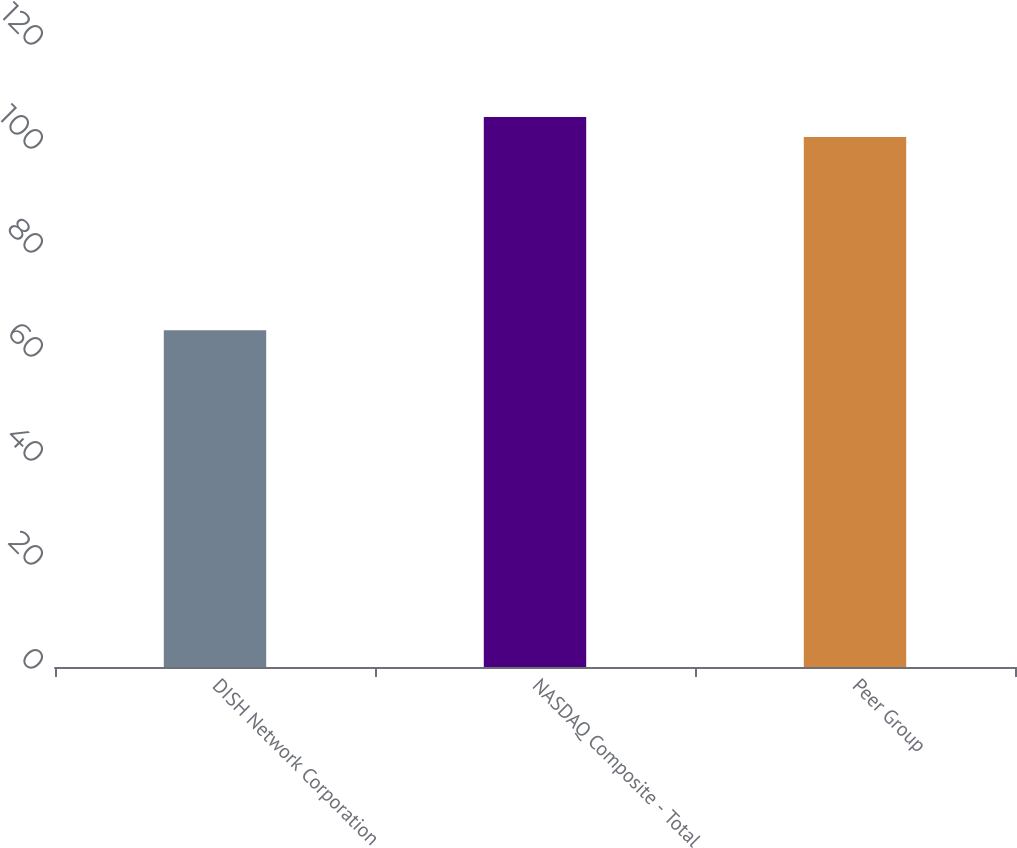<chart> <loc_0><loc_0><loc_500><loc_500><bar_chart><fcel>DISH Network Corporation<fcel>NASDAQ Composite - Total<fcel>Peer Group<nl><fcel>64.77<fcel>105.77<fcel>101.94<nl></chart> 